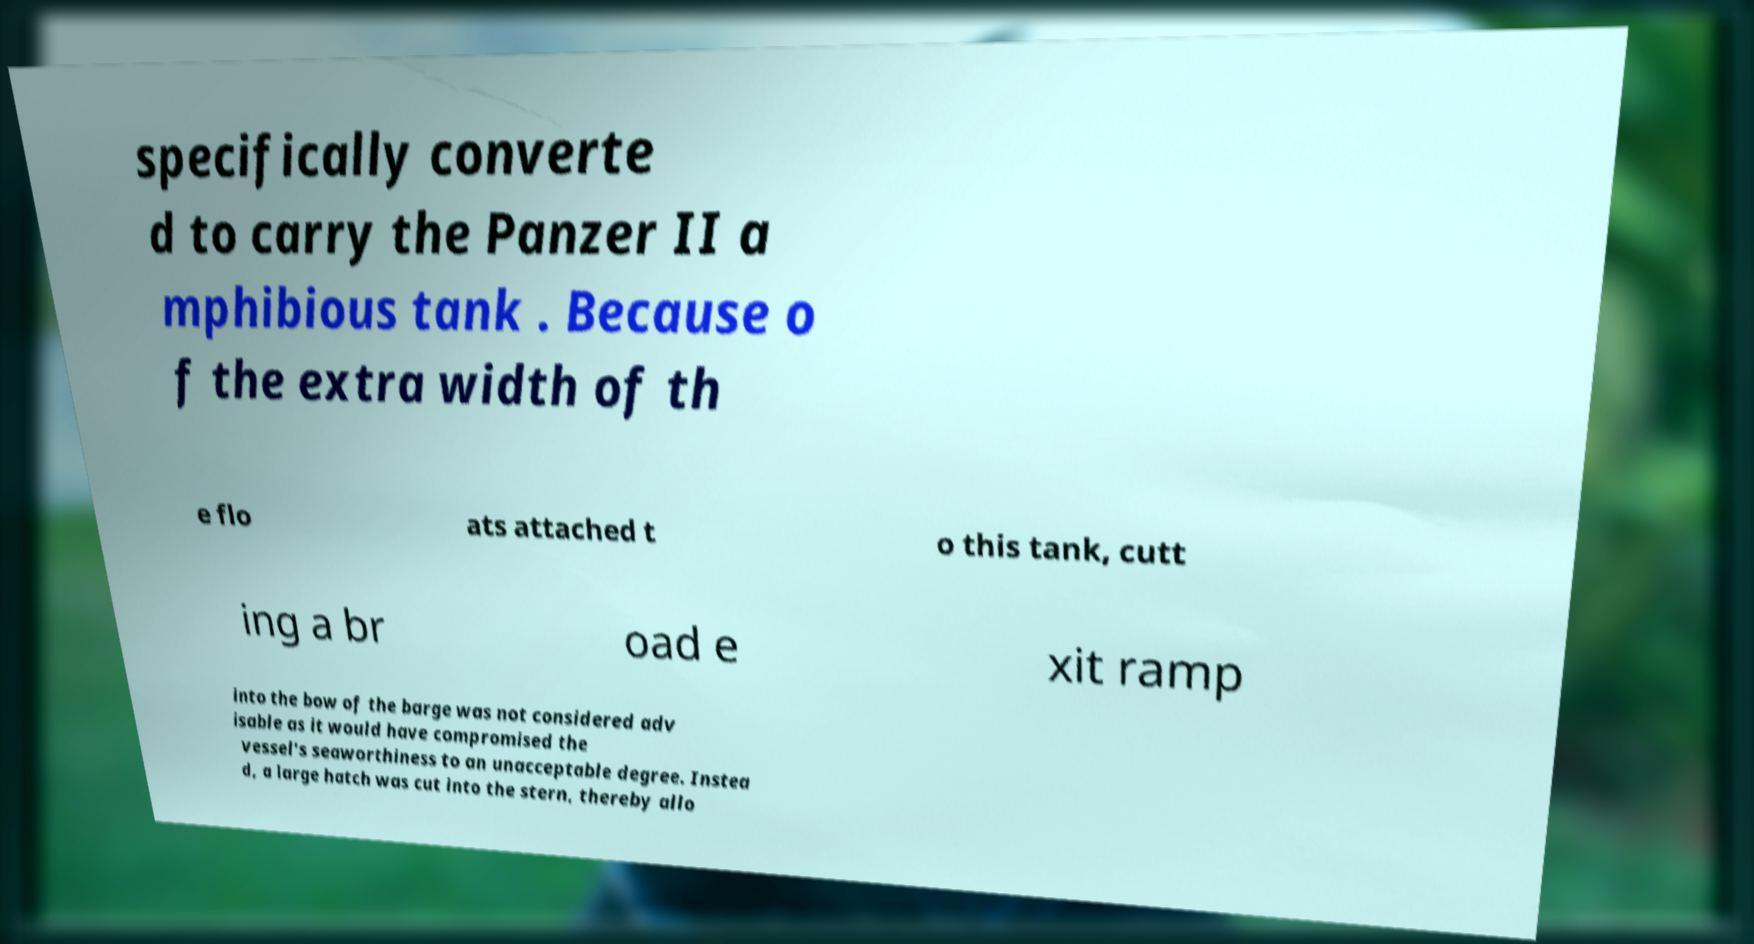Could you extract and type out the text from this image? specifically converte d to carry the Panzer II a mphibious tank . Because o f the extra width of th e flo ats attached t o this tank, cutt ing a br oad e xit ramp into the bow of the barge was not considered adv isable as it would have compromised the vessel's seaworthiness to an unacceptable degree. Instea d, a large hatch was cut into the stern, thereby allo 